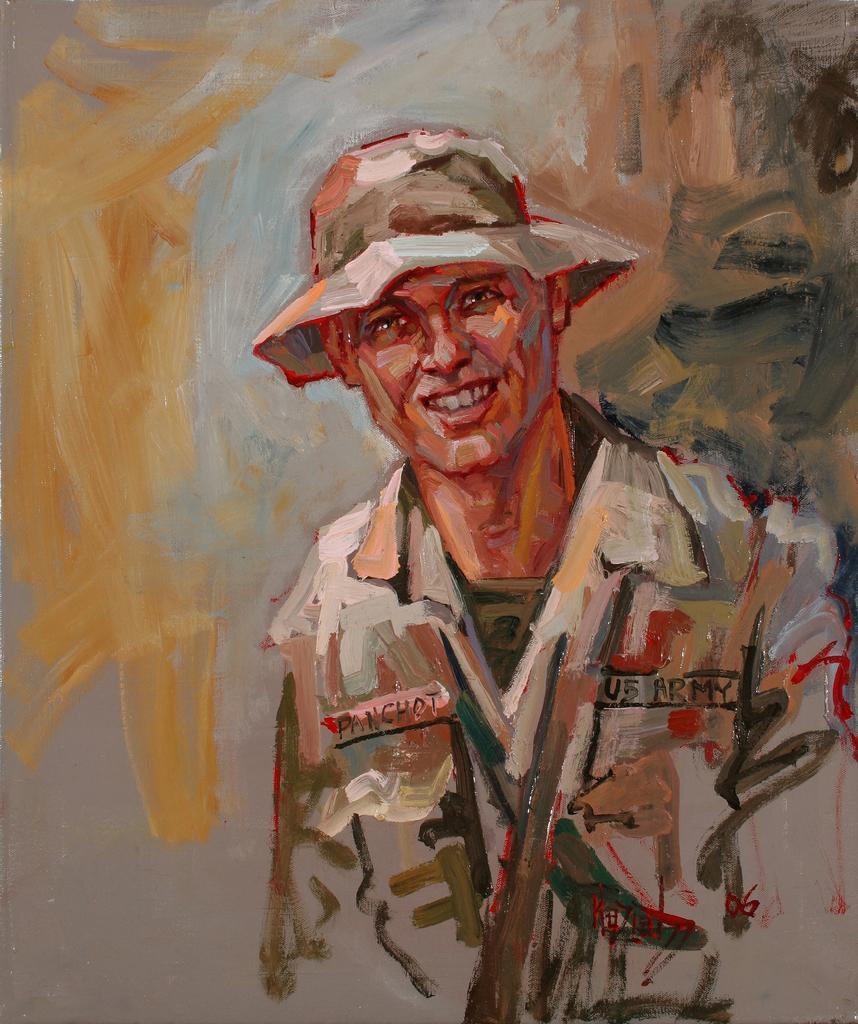How would you summarize this image in a sentence or two? In this image, we can see a painting of a man wearing a hat. In the background, we can see some different colors. 